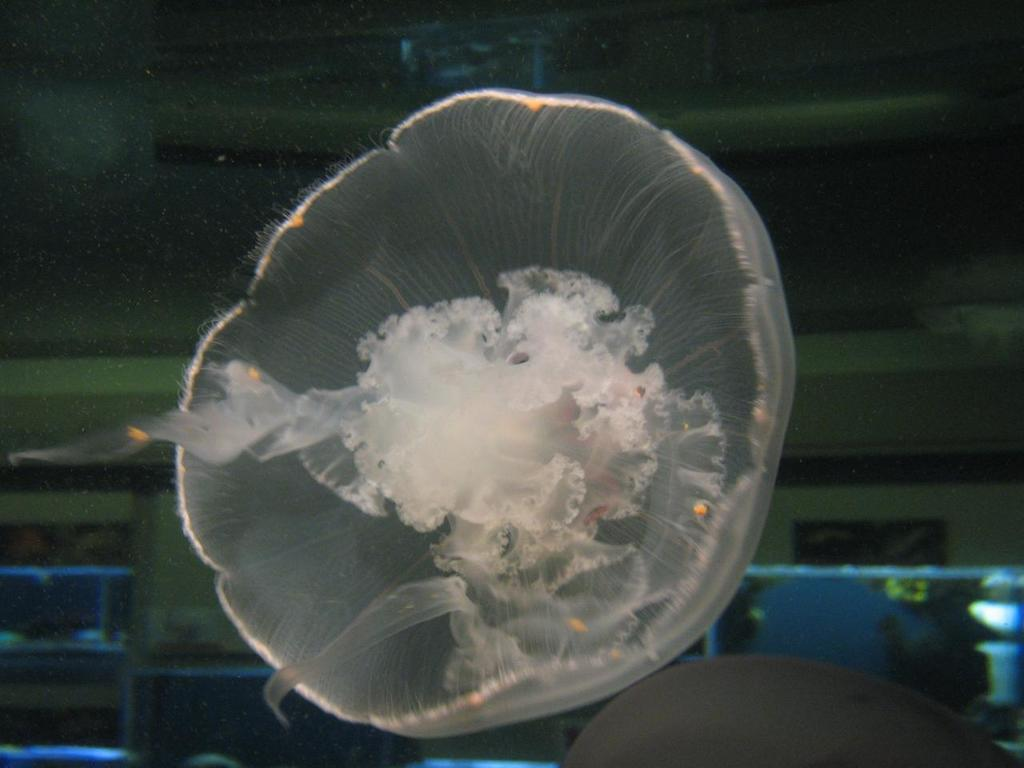What is the main subject in the foreground of the image? There is a jellyfish in the foreground of the image. What can be seen in the background of the image? There is a wall in the background of the image. Are there any other objects visible in the background? Yes, there are some objects in the background of the image. What is the interest rate of the loan mentioned in the image? There is no mention of a loan or interest rate in the image; it features a jellyfish in the foreground and a wall in the background. How many pigs are visible in the image? There are no pigs present in the image. 